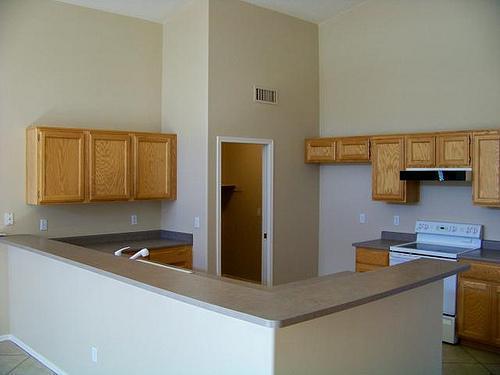How many vents are shown?
Give a very brief answer. 1. 